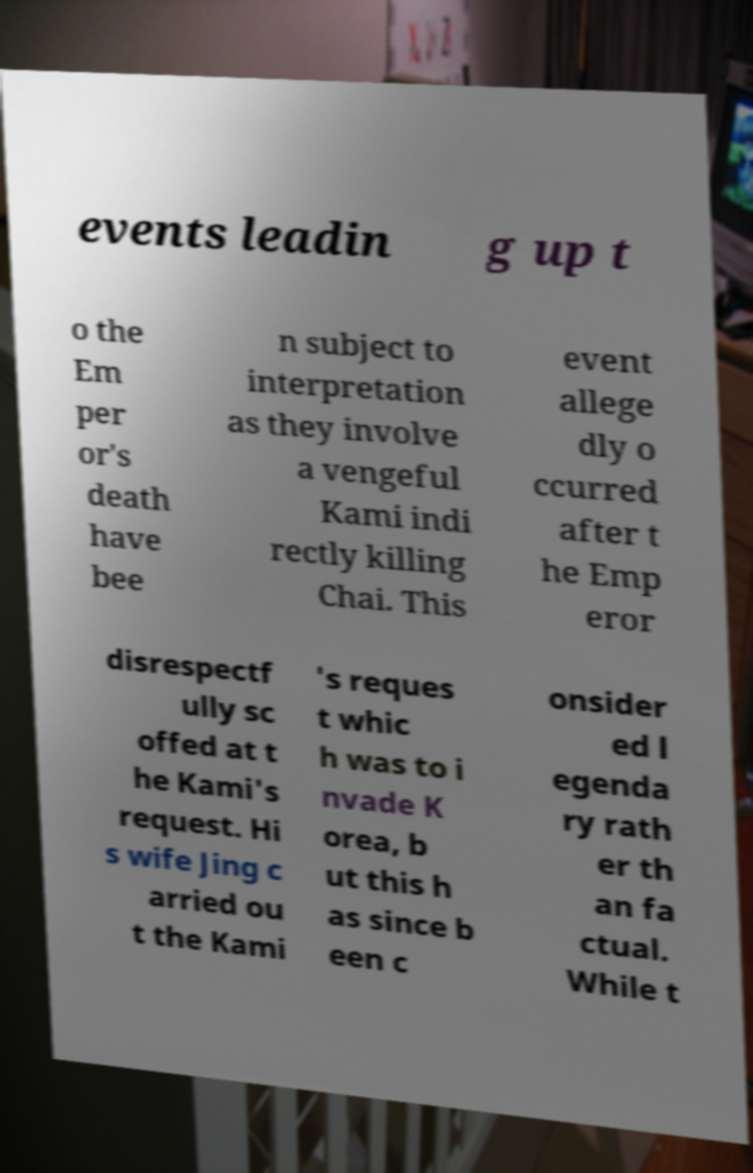Could you assist in decoding the text presented in this image and type it out clearly? events leadin g up t o the Em per or's death have bee n subject to interpretation as they involve a vengeful Kami indi rectly killing Chai. This event allege dly o ccurred after t he Emp eror disrespectf ully sc offed at t he Kami's request. Hi s wife Jing c arried ou t the Kami 's reques t whic h was to i nvade K orea, b ut this h as since b een c onsider ed l egenda ry rath er th an fa ctual. While t 